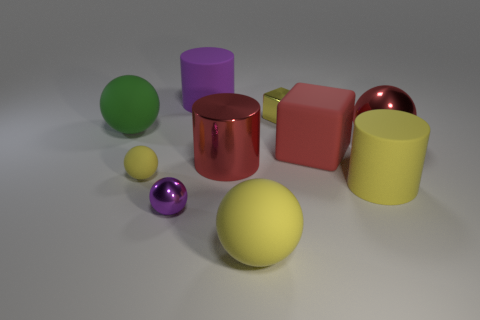What number of big objects are shiny balls or brown rubber cubes?
Offer a very short reply. 1. What size is the cylinder that is both to the left of the big yellow sphere and in front of the large purple thing?
Make the answer very short. Large. There is a tiny metal block; how many large red matte cubes are behind it?
Provide a short and direct response. 0. The tiny object that is both behind the yellow matte cylinder and on the right side of the small matte ball has what shape?
Give a very brief answer. Cube. There is a big cylinder that is the same color as the small matte object; what is its material?
Provide a short and direct response. Rubber. How many cylinders are purple matte objects or rubber things?
Offer a terse response. 2. The cylinder that is the same color as the small matte thing is what size?
Make the answer very short. Large. Are there fewer big green spheres that are on the right side of the tiny yellow metal object than yellow cylinders?
Offer a terse response. Yes. There is a big rubber thing that is both in front of the tiny yellow ball and on the left side of the yellow metallic object; what is its color?
Keep it short and to the point. Yellow. How many other objects are there of the same shape as the tiny matte thing?
Offer a very short reply. 4. 